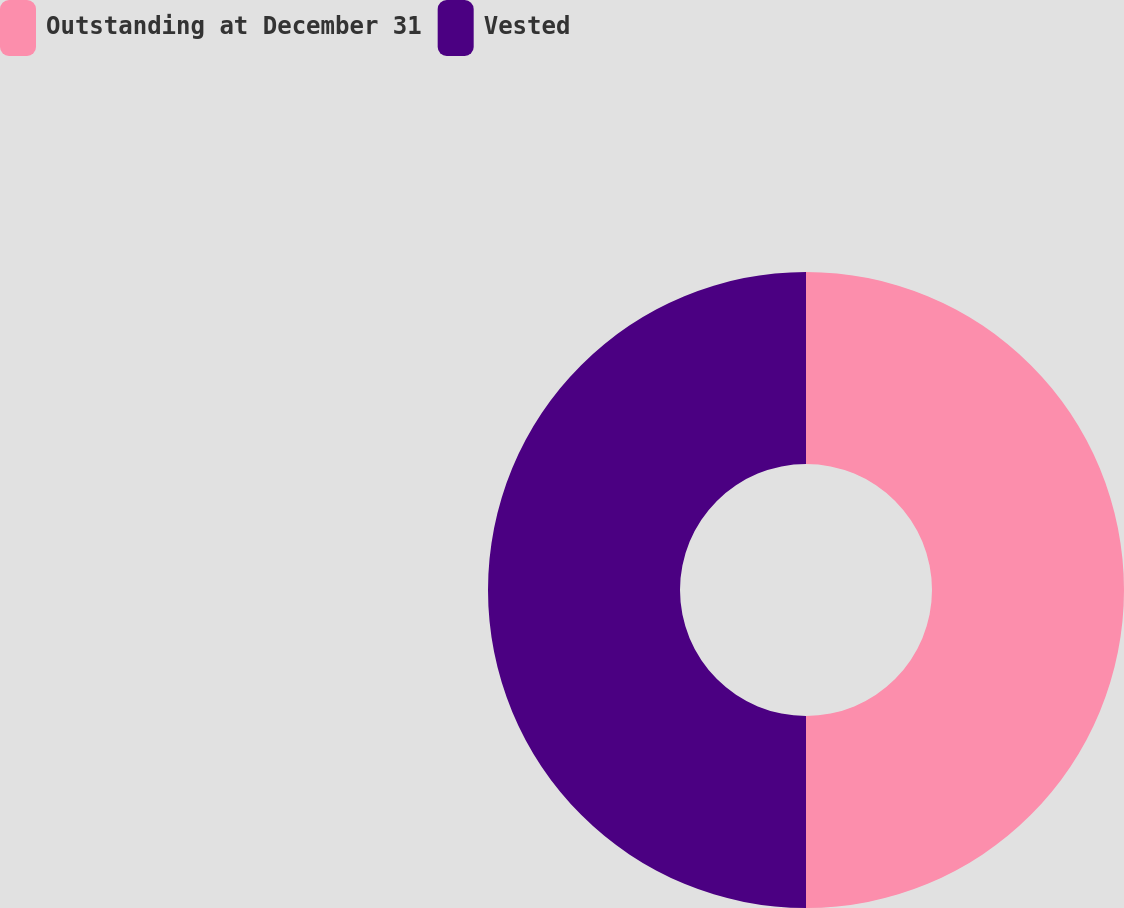Convert chart to OTSL. <chart><loc_0><loc_0><loc_500><loc_500><pie_chart><fcel>Outstanding at December 31<fcel>Vested<nl><fcel>50.0%<fcel>50.0%<nl></chart> 